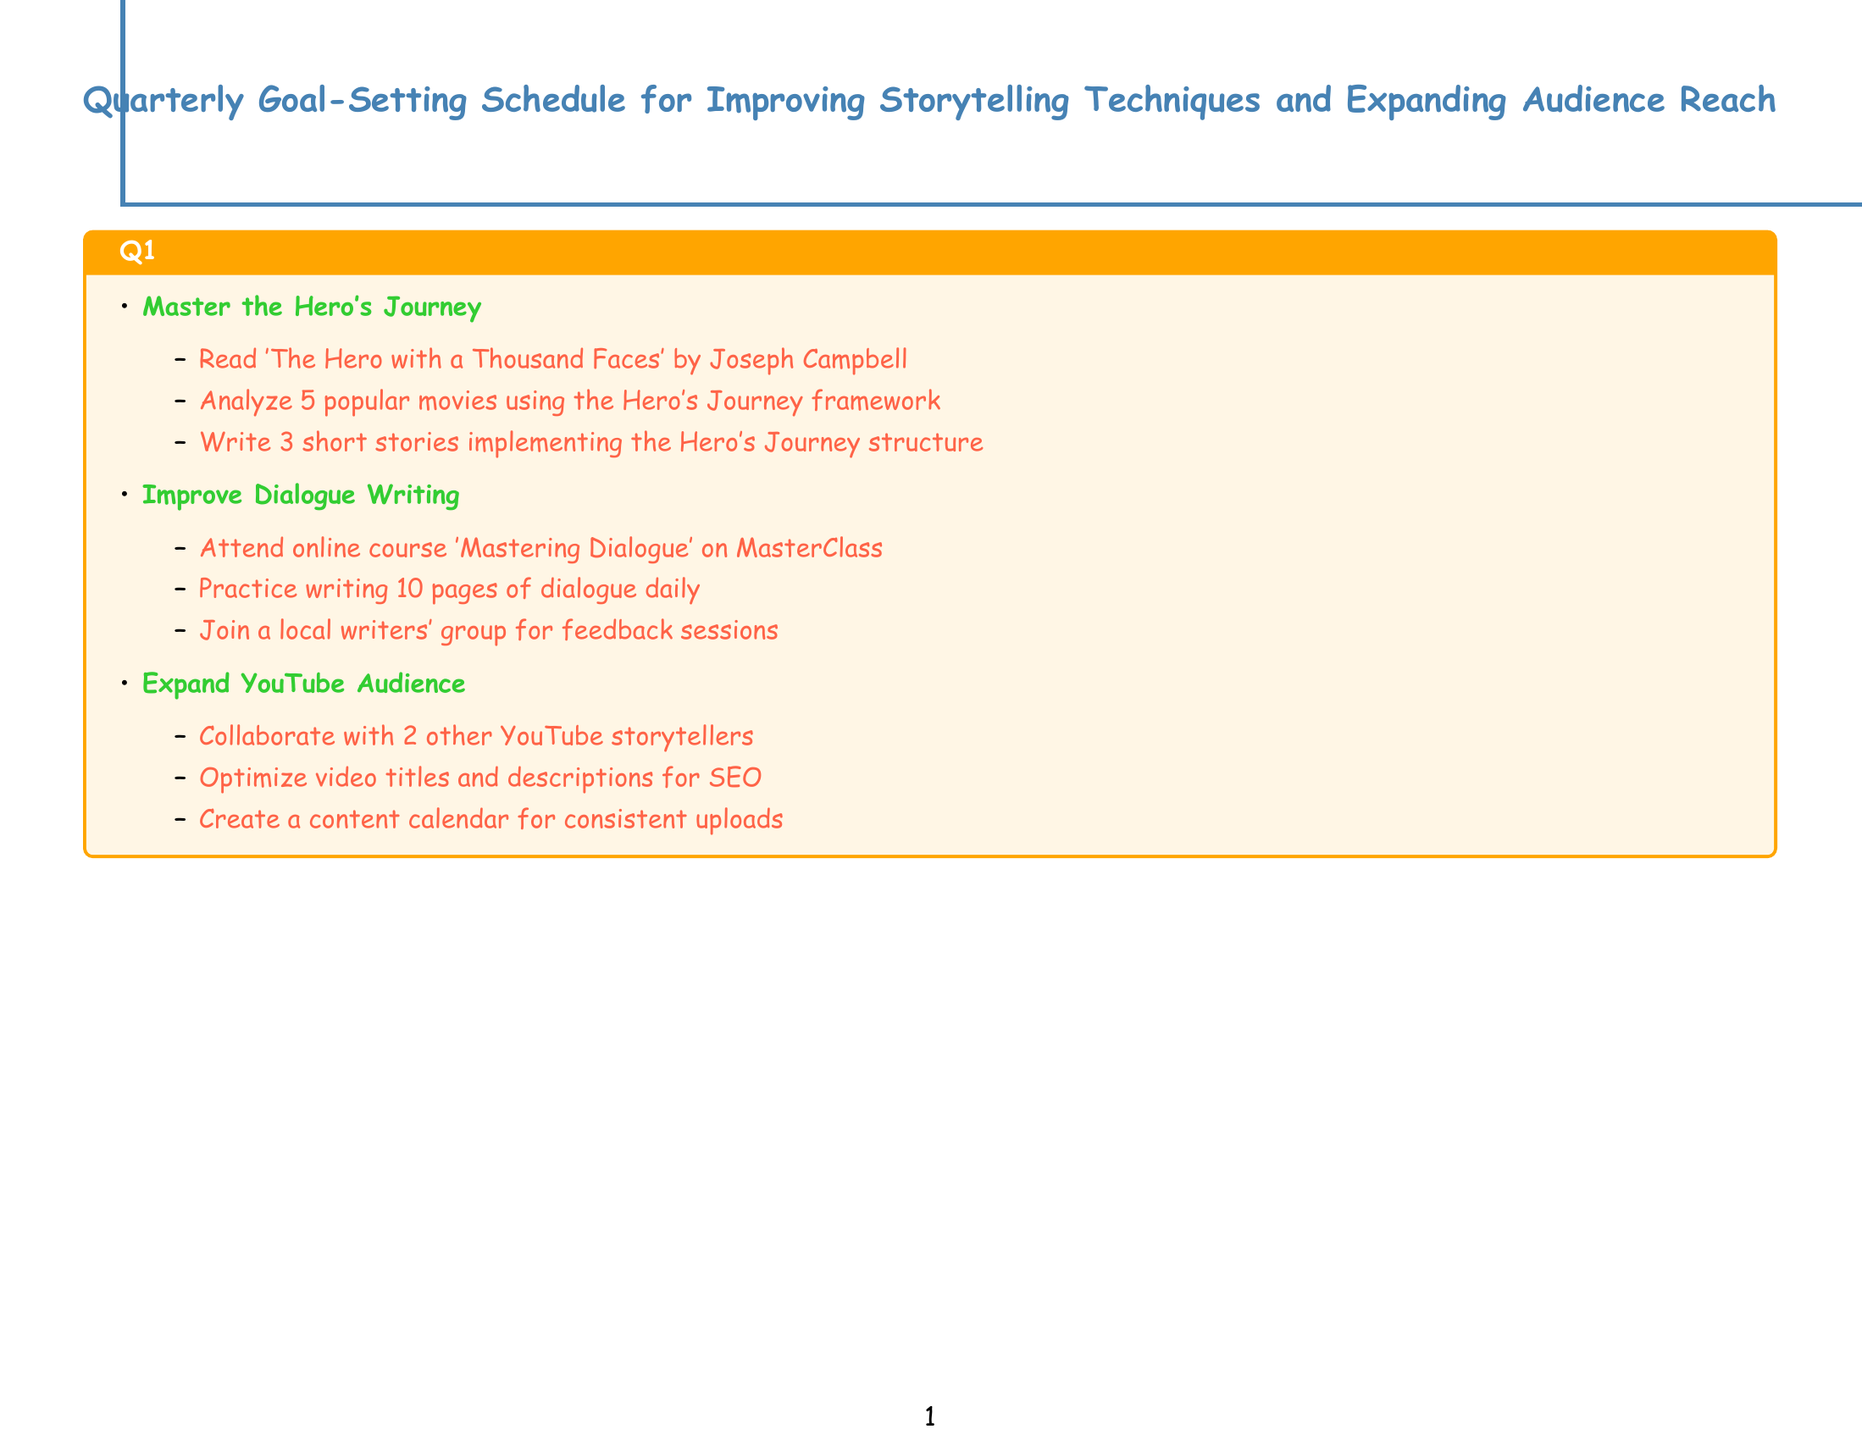What is the title of the goal for Q1 focusing on dialogue? The title for Q1 focusing on dialogue is listed in the goals section.
Answer: Improve Dialogue Writing How many short stories are written in the first goal of Q1? The goal of mastering the Hero's Journey includes writing three short stories.
Answer: 3 What is the course taken in Q2 to develop world-building skills? The activity involves reading a specific book listed under developing world-building skills.
Answer: The Guide to Writing Fantasy and Science Fiction Which social media platforms are mentioned in Q3 for audience expansion? The document specifies creating accounts on certain platforms for short-form content.
Answer: TikTok and Instagram How many activities are listed under the goal of launching a storytelling podcast in Q4? Each goal has a set number of activities detailed underneath it, with the podcast having three.
Answer: 3 What is the primary focus of Q4's first goal? The title of the first goal of Q4 indicates its focus on storytelling techniques.
Answer: Experimental Storytelling How many bestselling novels should be analyzed for mastering plot structures in Q3? The document specifies an analysis of a number of popular novels to gain insights.
Answer: 10 What emotional aspect is targeted for improvement in Q4? The goal explicitly mentions enhancing a specific emotional element in stories.
Answer: Emotional Impact 